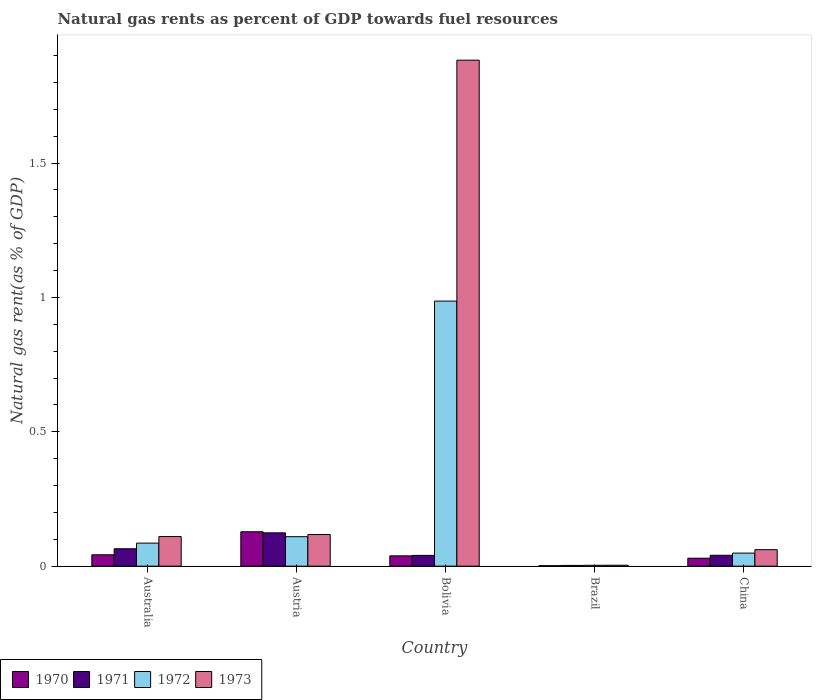How many different coloured bars are there?
Your response must be concise. 4. How many groups of bars are there?
Keep it short and to the point. 5. Are the number of bars on each tick of the X-axis equal?
Provide a short and direct response. Yes. What is the label of the 2nd group of bars from the left?
Give a very brief answer. Austria. In how many cases, is the number of bars for a given country not equal to the number of legend labels?
Provide a succinct answer. 0. What is the natural gas rent in 1971 in Brazil?
Keep it short and to the point. 0. Across all countries, what is the maximum natural gas rent in 1972?
Your response must be concise. 0.99. Across all countries, what is the minimum natural gas rent in 1973?
Provide a succinct answer. 0. In which country was the natural gas rent in 1971 minimum?
Provide a short and direct response. Brazil. What is the total natural gas rent in 1971 in the graph?
Your answer should be compact. 0.27. What is the difference between the natural gas rent in 1972 in Austria and that in Brazil?
Your answer should be very brief. 0.11. What is the difference between the natural gas rent in 1972 in Brazil and the natural gas rent in 1971 in Australia?
Your answer should be very brief. -0.06. What is the average natural gas rent in 1971 per country?
Give a very brief answer. 0.05. What is the difference between the natural gas rent of/in 1970 and natural gas rent of/in 1971 in Brazil?
Offer a very short reply. -0. What is the ratio of the natural gas rent in 1972 in Austria to that in Bolivia?
Your answer should be compact. 0.11. Is the natural gas rent in 1970 in Austria less than that in Brazil?
Ensure brevity in your answer.  No. What is the difference between the highest and the second highest natural gas rent in 1973?
Your answer should be very brief. -1.77. What is the difference between the highest and the lowest natural gas rent in 1972?
Provide a short and direct response. 0.98. In how many countries, is the natural gas rent in 1971 greater than the average natural gas rent in 1971 taken over all countries?
Your answer should be compact. 2. Is it the case that in every country, the sum of the natural gas rent in 1970 and natural gas rent in 1972 is greater than the sum of natural gas rent in 1971 and natural gas rent in 1973?
Offer a terse response. No. How many bars are there?
Keep it short and to the point. 20. Are all the bars in the graph horizontal?
Provide a short and direct response. No. Are the values on the major ticks of Y-axis written in scientific E-notation?
Provide a short and direct response. No. Does the graph contain any zero values?
Make the answer very short. No. Where does the legend appear in the graph?
Your answer should be very brief. Bottom left. How many legend labels are there?
Provide a succinct answer. 4. How are the legend labels stacked?
Provide a short and direct response. Horizontal. What is the title of the graph?
Your answer should be very brief. Natural gas rents as percent of GDP towards fuel resources. Does "1972" appear as one of the legend labels in the graph?
Your answer should be very brief. Yes. What is the label or title of the Y-axis?
Offer a terse response. Natural gas rent(as % of GDP). What is the Natural gas rent(as % of GDP) of 1970 in Australia?
Make the answer very short. 0.04. What is the Natural gas rent(as % of GDP) of 1971 in Australia?
Your answer should be very brief. 0.06. What is the Natural gas rent(as % of GDP) of 1972 in Australia?
Ensure brevity in your answer.  0.09. What is the Natural gas rent(as % of GDP) in 1973 in Australia?
Your answer should be very brief. 0.11. What is the Natural gas rent(as % of GDP) of 1970 in Austria?
Ensure brevity in your answer.  0.13. What is the Natural gas rent(as % of GDP) in 1971 in Austria?
Give a very brief answer. 0.12. What is the Natural gas rent(as % of GDP) of 1972 in Austria?
Offer a very short reply. 0.11. What is the Natural gas rent(as % of GDP) of 1973 in Austria?
Give a very brief answer. 0.12. What is the Natural gas rent(as % of GDP) in 1970 in Bolivia?
Offer a very short reply. 0.04. What is the Natural gas rent(as % of GDP) in 1971 in Bolivia?
Ensure brevity in your answer.  0.04. What is the Natural gas rent(as % of GDP) of 1972 in Bolivia?
Provide a short and direct response. 0.99. What is the Natural gas rent(as % of GDP) in 1973 in Bolivia?
Your answer should be very brief. 1.88. What is the Natural gas rent(as % of GDP) of 1970 in Brazil?
Make the answer very short. 0. What is the Natural gas rent(as % of GDP) in 1971 in Brazil?
Keep it short and to the point. 0. What is the Natural gas rent(as % of GDP) in 1972 in Brazil?
Your answer should be compact. 0. What is the Natural gas rent(as % of GDP) in 1973 in Brazil?
Keep it short and to the point. 0. What is the Natural gas rent(as % of GDP) of 1970 in China?
Provide a succinct answer. 0.03. What is the Natural gas rent(as % of GDP) in 1971 in China?
Offer a very short reply. 0.04. What is the Natural gas rent(as % of GDP) in 1972 in China?
Offer a very short reply. 0.05. What is the Natural gas rent(as % of GDP) in 1973 in China?
Your answer should be compact. 0.06. Across all countries, what is the maximum Natural gas rent(as % of GDP) in 1970?
Your answer should be very brief. 0.13. Across all countries, what is the maximum Natural gas rent(as % of GDP) in 1971?
Make the answer very short. 0.12. Across all countries, what is the maximum Natural gas rent(as % of GDP) in 1972?
Give a very brief answer. 0.99. Across all countries, what is the maximum Natural gas rent(as % of GDP) of 1973?
Provide a succinct answer. 1.88. Across all countries, what is the minimum Natural gas rent(as % of GDP) in 1970?
Keep it short and to the point. 0. Across all countries, what is the minimum Natural gas rent(as % of GDP) of 1971?
Provide a short and direct response. 0. Across all countries, what is the minimum Natural gas rent(as % of GDP) in 1972?
Offer a very short reply. 0. Across all countries, what is the minimum Natural gas rent(as % of GDP) in 1973?
Your response must be concise. 0. What is the total Natural gas rent(as % of GDP) of 1970 in the graph?
Offer a very short reply. 0.24. What is the total Natural gas rent(as % of GDP) of 1971 in the graph?
Offer a terse response. 0.27. What is the total Natural gas rent(as % of GDP) of 1972 in the graph?
Keep it short and to the point. 1.23. What is the total Natural gas rent(as % of GDP) in 1973 in the graph?
Offer a terse response. 2.18. What is the difference between the Natural gas rent(as % of GDP) of 1970 in Australia and that in Austria?
Provide a short and direct response. -0.09. What is the difference between the Natural gas rent(as % of GDP) of 1971 in Australia and that in Austria?
Your answer should be very brief. -0.06. What is the difference between the Natural gas rent(as % of GDP) of 1972 in Australia and that in Austria?
Ensure brevity in your answer.  -0.02. What is the difference between the Natural gas rent(as % of GDP) of 1973 in Australia and that in Austria?
Ensure brevity in your answer.  -0.01. What is the difference between the Natural gas rent(as % of GDP) of 1970 in Australia and that in Bolivia?
Your response must be concise. 0. What is the difference between the Natural gas rent(as % of GDP) in 1971 in Australia and that in Bolivia?
Provide a short and direct response. 0.02. What is the difference between the Natural gas rent(as % of GDP) of 1972 in Australia and that in Bolivia?
Make the answer very short. -0.9. What is the difference between the Natural gas rent(as % of GDP) in 1973 in Australia and that in Bolivia?
Your answer should be compact. -1.77. What is the difference between the Natural gas rent(as % of GDP) in 1970 in Australia and that in Brazil?
Your answer should be compact. 0.04. What is the difference between the Natural gas rent(as % of GDP) in 1971 in Australia and that in Brazil?
Give a very brief answer. 0.06. What is the difference between the Natural gas rent(as % of GDP) in 1972 in Australia and that in Brazil?
Make the answer very short. 0.08. What is the difference between the Natural gas rent(as % of GDP) of 1973 in Australia and that in Brazil?
Ensure brevity in your answer.  0.11. What is the difference between the Natural gas rent(as % of GDP) of 1970 in Australia and that in China?
Your answer should be very brief. 0.01. What is the difference between the Natural gas rent(as % of GDP) of 1971 in Australia and that in China?
Provide a succinct answer. 0.02. What is the difference between the Natural gas rent(as % of GDP) of 1972 in Australia and that in China?
Offer a very short reply. 0.04. What is the difference between the Natural gas rent(as % of GDP) of 1973 in Australia and that in China?
Make the answer very short. 0.05. What is the difference between the Natural gas rent(as % of GDP) in 1970 in Austria and that in Bolivia?
Offer a terse response. 0.09. What is the difference between the Natural gas rent(as % of GDP) of 1971 in Austria and that in Bolivia?
Ensure brevity in your answer.  0.08. What is the difference between the Natural gas rent(as % of GDP) of 1972 in Austria and that in Bolivia?
Ensure brevity in your answer.  -0.88. What is the difference between the Natural gas rent(as % of GDP) in 1973 in Austria and that in Bolivia?
Offer a very short reply. -1.77. What is the difference between the Natural gas rent(as % of GDP) of 1970 in Austria and that in Brazil?
Your answer should be compact. 0.13. What is the difference between the Natural gas rent(as % of GDP) of 1971 in Austria and that in Brazil?
Provide a succinct answer. 0.12. What is the difference between the Natural gas rent(as % of GDP) of 1972 in Austria and that in Brazil?
Your answer should be very brief. 0.11. What is the difference between the Natural gas rent(as % of GDP) in 1973 in Austria and that in Brazil?
Give a very brief answer. 0.11. What is the difference between the Natural gas rent(as % of GDP) of 1970 in Austria and that in China?
Your answer should be compact. 0.1. What is the difference between the Natural gas rent(as % of GDP) in 1971 in Austria and that in China?
Your response must be concise. 0.08. What is the difference between the Natural gas rent(as % of GDP) of 1972 in Austria and that in China?
Provide a succinct answer. 0.06. What is the difference between the Natural gas rent(as % of GDP) in 1973 in Austria and that in China?
Offer a terse response. 0.06. What is the difference between the Natural gas rent(as % of GDP) of 1970 in Bolivia and that in Brazil?
Provide a succinct answer. 0.04. What is the difference between the Natural gas rent(as % of GDP) in 1971 in Bolivia and that in Brazil?
Offer a very short reply. 0.04. What is the difference between the Natural gas rent(as % of GDP) in 1972 in Bolivia and that in Brazil?
Keep it short and to the point. 0.98. What is the difference between the Natural gas rent(as % of GDP) in 1973 in Bolivia and that in Brazil?
Provide a succinct answer. 1.88. What is the difference between the Natural gas rent(as % of GDP) of 1970 in Bolivia and that in China?
Give a very brief answer. 0.01. What is the difference between the Natural gas rent(as % of GDP) of 1971 in Bolivia and that in China?
Keep it short and to the point. -0. What is the difference between the Natural gas rent(as % of GDP) in 1972 in Bolivia and that in China?
Provide a short and direct response. 0.94. What is the difference between the Natural gas rent(as % of GDP) of 1973 in Bolivia and that in China?
Ensure brevity in your answer.  1.82. What is the difference between the Natural gas rent(as % of GDP) in 1970 in Brazil and that in China?
Give a very brief answer. -0.03. What is the difference between the Natural gas rent(as % of GDP) of 1971 in Brazil and that in China?
Make the answer very short. -0.04. What is the difference between the Natural gas rent(as % of GDP) in 1972 in Brazil and that in China?
Offer a very short reply. -0.05. What is the difference between the Natural gas rent(as % of GDP) in 1973 in Brazil and that in China?
Your answer should be very brief. -0.06. What is the difference between the Natural gas rent(as % of GDP) of 1970 in Australia and the Natural gas rent(as % of GDP) of 1971 in Austria?
Provide a succinct answer. -0.08. What is the difference between the Natural gas rent(as % of GDP) of 1970 in Australia and the Natural gas rent(as % of GDP) of 1972 in Austria?
Your answer should be compact. -0.07. What is the difference between the Natural gas rent(as % of GDP) in 1970 in Australia and the Natural gas rent(as % of GDP) in 1973 in Austria?
Keep it short and to the point. -0.08. What is the difference between the Natural gas rent(as % of GDP) of 1971 in Australia and the Natural gas rent(as % of GDP) of 1972 in Austria?
Make the answer very short. -0.04. What is the difference between the Natural gas rent(as % of GDP) in 1971 in Australia and the Natural gas rent(as % of GDP) in 1973 in Austria?
Provide a succinct answer. -0.05. What is the difference between the Natural gas rent(as % of GDP) of 1972 in Australia and the Natural gas rent(as % of GDP) of 1973 in Austria?
Provide a short and direct response. -0.03. What is the difference between the Natural gas rent(as % of GDP) in 1970 in Australia and the Natural gas rent(as % of GDP) in 1971 in Bolivia?
Provide a short and direct response. 0. What is the difference between the Natural gas rent(as % of GDP) in 1970 in Australia and the Natural gas rent(as % of GDP) in 1972 in Bolivia?
Keep it short and to the point. -0.94. What is the difference between the Natural gas rent(as % of GDP) of 1970 in Australia and the Natural gas rent(as % of GDP) of 1973 in Bolivia?
Your answer should be very brief. -1.84. What is the difference between the Natural gas rent(as % of GDP) of 1971 in Australia and the Natural gas rent(as % of GDP) of 1972 in Bolivia?
Ensure brevity in your answer.  -0.92. What is the difference between the Natural gas rent(as % of GDP) in 1971 in Australia and the Natural gas rent(as % of GDP) in 1973 in Bolivia?
Offer a terse response. -1.82. What is the difference between the Natural gas rent(as % of GDP) in 1972 in Australia and the Natural gas rent(as % of GDP) in 1973 in Bolivia?
Offer a very short reply. -1.8. What is the difference between the Natural gas rent(as % of GDP) in 1970 in Australia and the Natural gas rent(as % of GDP) in 1971 in Brazil?
Keep it short and to the point. 0.04. What is the difference between the Natural gas rent(as % of GDP) in 1970 in Australia and the Natural gas rent(as % of GDP) in 1972 in Brazil?
Your answer should be compact. 0.04. What is the difference between the Natural gas rent(as % of GDP) in 1970 in Australia and the Natural gas rent(as % of GDP) in 1973 in Brazil?
Give a very brief answer. 0.04. What is the difference between the Natural gas rent(as % of GDP) in 1971 in Australia and the Natural gas rent(as % of GDP) in 1972 in Brazil?
Give a very brief answer. 0.06. What is the difference between the Natural gas rent(as % of GDP) of 1971 in Australia and the Natural gas rent(as % of GDP) of 1973 in Brazil?
Your response must be concise. 0.06. What is the difference between the Natural gas rent(as % of GDP) in 1972 in Australia and the Natural gas rent(as % of GDP) in 1973 in Brazil?
Your answer should be very brief. 0.08. What is the difference between the Natural gas rent(as % of GDP) in 1970 in Australia and the Natural gas rent(as % of GDP) in 1971 in China?
Give a very brief answer. 0. What is the difference between the Natural gas rent(as % of GDP) in 1970 in Australia and the Natural gas rent(as % of GDP) in 1972 in China?
Make the answer very short. -0.01. What is the difference between the Natural gas rent(as % of GDP) of 1970 in Australia and the Natural gas rent(as % of GDP) of 1973 in China?
Your answer should be compact. -0.02. What is the difference between the Natural gas rent(as % of GDP) in 1971 in Australia and the Natural gas rent(as % of GDP) in 1972 in China?
Your answer should be compact. 0.02. What is the difference between the Natural gas rent(as % of GDP) in 1971 in Australia and the Natural gas rent(as % of GDP) in 1973 in China?
Ensure brevity in your answer.  0. What is the difference between the Natural gas rent(as % of GDP) in 1972 in Australia and the Natural gas rent(as % of GDP) in 1973 in China?
Provide a short and direct response. 0.02. What is the difference between the Natural gas rent(as % of GDP) of 1970 in Austria and the Natural gas rent(as % of GDP) of 1971 in Bolivia?
Make the answer very short. 0.09. What is the difference between the Natural gas rent(as % of GDP) in 1970 in Austria and the Natural gas rent(as % of GDP) in 1972 in Bolivia?
Your answer should be compact. -0.86. What is the difference between the Natural gas rent(as % of GDP) of 1970 in Austria and the Natural gas rent(as % of GDP) of 1973 in Bolivia?
Keep it short and to the point. -1.75. What is the difference between the Natural gas rent(as % of GDP) in 1971 in Austria and the Natural gas rent(as % of GDP) in 1972 in Bolivia?
Provide a succinct answer. -0.86. What is the difference between the Natural gas rent(as % of GDP) of 1971 in Austria and the Natural gas rent(as % of GDP) of 1973 in Bolivia?
Ensure brevity in your answer.  -1.76. What is the difference between the Natural gas rent(as % of GDP) in 1972 in Austria and the Natural gas rent(as % of GDP) in 1973 in Bolivia?
Your response must be concise. -1.77. What is the difference between the Natural gas rent(as % of GDP) in 1970 in Austria and the Natural gas rent(as % of GDP) in 1971 in Brazil?
Your response must be concise. 0.13. What is the difference between the Natural gas rent(as % of GDP) of 1970 in Austria and the Natural gas rent(as % of GDP) of 1972 in Brazil?
Give a very brief answer. 0.12. What is the difference between the Natural gas rent(as % of GDP) in 1970 in Austria and the Natural gas rent(as % of GDP) in 1973 in Brazil?
Offer a terse response. 0.12. What is the difference between the Natural gas rent(as % of GDP) in 1971 in Austria and the Natural gas rent(as % of GDP) in 1972 in Brazil?
Give a very brief answer. 0.12. What is the difference between the Natural gas rent(as % of GDP) in 1971 in Austria and the Natural gas rent(as % of GDP) in 1973 in Brazil?
Offer a terse response. 0.12. What is the difference between the Natural gas rent(as % of GDP) of 1972 in Austria and the Natural gas rent(as % of GDP) of 1973 in Brazil?
Keep it short and to the point. 0.11. What is the difference between the Natural gas rent(as % of GDP) in 1970 in Austria and the Natural gas rent(as % of GDP) in 1971 in China?
Provide a short and direct response. 0.09. What is the difference between the Natural gas rent(as % of GDP) in 1970 in Austria and the Natural gas rent(as % of GDP) in 1972 in China?
Your response must be concise. 0.08. What is the difference between the Natural gas rent(as % of GDP) in 1970 in Austria and the Natural gas rent(as % of GDP) in 1973 in China?
Give a very brief answer. 0.07. What is the difference between the Natural gas rent(as % of GDP) of 1971 in Austria and the Natural gas rent(as % of GDP) of 1972 in China?
Ensure brevity in your answer.  0.08. What is the difference between the Natural gas rent(as % of GDP) of 1971 in Austria and the Natural gas rent(as % of GDP) of 1973 in China?
Provide a short and direct response. 0.06. What is the difference between the Natural gas rent(as % of GDP) of 1972 in Austria and the Natural gas rent(as % of GDP) of 1973 in China?
Offer a very short reply. 0.05. What is the difference between the Natural gas rent(as % of GDP) of 1970 in Bolivia and the Natural gas rent(as % of GDP) of 1971 in Brazil?
Offer a terse response. 0.04. What is the difference between the Natural gas rent(as % of GDP) in 1970 in Bolivia and the Natural gas rent(as % of GDP) in 1972 in Brazil?
Your response must be concise. 0.04. What is the difference between the Natural gas rent(as % of GDP) of 1970 in Bolivia and the Natural gas rent(as % of GDP) of 1973 in Brazil?
Provide a succinct answer. 0.03. What is the difference between the Natural gas rent(as % of GDP) of 1971 in Bolivia and the Natural gas rent(as % of GDP) of 1972 in Brazil?
Your answer should be very brief. 0.04. What is the difference between the Natural gas rent(as % of GDP) of 1971 in Bolivia and the Natural gas rent(as % of GDP) of 1973 in Brazil?
Give a very brief answer. 0.04. What is the difference between the Natural gas rent(as % of GDP) of 1972 in Bolivia and the Natural gas rent(as % of GDP) of 1973 in Brazil?
Make the answer very short. 0.98. What is the difference between the Natural gas rent(as % of GDP) of 1970 in Bolivia and the Natural gas rent(as % of GDP) of 1971 in China?
Provide a short and direct response. -0. What is the difference between the Natural gas rent(as % of GDP) of 1970 in Bolivia and the Natural gas rent(as % of GDP) of 1972 in China?
Ensure brevity in your answer.  -0.01. What is the difference between the Natural gas rent(as % of GDP) in 1970 in Bolivia and the Natural gas rent(as % of GDP) in 1973 in China?
Your response must be concise. -0.02. What is the difference between the Natural gas rent(as % of GDP) of 1971 in Bolivia and the Natural gas rent(as % of GDP) of 1972 in China?
Keep it short and to the point. -0.01. What is the difference between the Natural gas rent(as % of GDP) of 1971 in Bolivia and the Natural gas rent(as % of GDP) of 1973 in China?
Your answer should be very brief. -0.02. What is the difference between the Natural gas rent(as % of GDP) of 1972 in Bolivia and the Natural gas rent(as % of GDP) of 1973 in China?
Your answer should be compact. 0.92. What is the difference between the Natural gas rent(as % of GDP) of 1970 in Brazil and the Natural gas rent(as % of GDP) of 1971 in China?
Ensure brevity in your answer.  -0.04. What is the difference between the Natural gas rent(as % of GDP) of 1970 in Brazil and the Natural gas rent(as % of GDP) of 1972 in China?
Offer a terse response. -0.05. What is the difference between the Natural gas rent(as % of GDP) in 1970 in Brazil and the Natural gas rent(as % of GDP) in 1973 in China?
Keep it short and to the point. -0.06. What is the difference between the Natural gas rent(as % of GDP) of 1971 in Brazil and the Natural gas rent(as % of GDP) of 1972 in China?
Ensure brevity in your answer.  -0.05. What is the difference between the Natural gas rent(as % of GDP) in 1971 in Brazil and the Natural gas rent(as % of GDP) in 1973 in China?
Your answer should be very brief. -0.06. What is the difference between the Natural gas rent(as % of GDP) of 1972 in Brazil and the Natural gas rent(as % of GDP) of 1973 in China?
Your answer should be very brief. -0.06. What is the average Natural gas rent(as % of GDP) of 1970 per country?
Your answer should be very brief. 0.05. What is the average Natural gas rent(as % of GDP) in 1971 per country?
Your response must be concise. 0.05. What is the average Natural gas rent(as % of GDP) in 1972 per country?
Offer a terse response. 0.25. What is the average Natural gas rent(as % of GDP) of 1973 per country?
Offer a very short reply. 0.44. What is the difference between the Natural gas rent(as % of GDP) of 1970 and Natural gas rent(as % of GDP) of 1971 in Australia?
Provide a short and direct response. -0.02. What is the difference between the Natural gas rent(as % of GDP) in 1970 and Natural gas rent(as % of GDP) in 1972 in Australia?
Offer a very short reply. -0.04. What is the difference between the Natural gas rent(as % of GDP) in 1970 and Natural gas rent(as % of GDP) in 1973 in Australia?
Your answer should be very brief. -0.07. What is the difference between the Natural gas rent(as % of GDP) of 1971 and Natural gas rent(as % of GDP) of 1972 in Australia?
Make the answer very short. -0.02. What is the difference between the Natural gas rent(as % of GDP) in 1971 and Natural gas rent(as % of GDP) in 1973 in Australia?
Give a very brief answer. -0.05. What is the difference between the Natural gas rent(as % of GDP) in 1972 and Natural gas rent(as % of GDP) in 1973 in Australia?
Keep it short and to the point. -0.02. What is the difference between the Natural gas rent(as % of GDP) in 1970 and Natural gas rent(as % of GDP) in 1971 in Austria?
Offer a terse response. 0. What is the difference between the Natural gas rent(as % of GDP) in 1970 and Natural gas rent(as % of GDP) in 1972 in Austria?
Keep it short and to the point. 0.02. What is the difference between the Natural gas rent(as % of GDP) of 1970 and Natural gas rent(as % of GDP) of 1973 in Austria?
Your answer should be compact. 0.01. What is the difference between the Natural gas rent(as % of GDP) of 1971 and Natural gas rent(as % of GDP) of 1972 in Austria?
Provide a short and direct response. 0.01. What is the difference between the Natural gas rent(as % of GDP) in 1971 and Natural gas rent(as % of GDP) in 1973 in Austria?
Offer a terse response. 0.01. What is the difference between the Natural gas rent(as % of GDP) of 1972 and Natural gas rent(as % of GDP) of 1973 in Austria?
Ensure brevity in your answer.  -0.01. What is the difference between the Natural gas rent(as % of GDP) of 1970 and Natural gas rent(as % of GDP) of 1971 in Bolivia?
Offer a very short reply. -0. What is the difference between the Natural gas rent(as % of GDP) of 1970 and Natural gas rent(as % of GDP) of 1972 in Bolivia?
Make the answer very short. -0.95. What is the difference between the Natural gas rent(as % of GDP) of 1970 and Natural gas rent(as % of GDP) of 1973 in Bolivia?
Give a very brief answer. -1.84. What is the difference between the Natural gas rent(as % of GDP) in 1971 and Natural gas rent(as % of GDP) in 1972 in Bolivia?
Offer a terse response. -0.95. What is the difference between the Natural gas rent(as % of GDP) in 1971 and Natural gas rent(as % of GDP) in 1973 in Bolivia?
Keep it short and to the point. -1.84. What is the difference between the Natural gas rent(as % of GDP) of 1972 and Natural gas rent(as % of GDP) of 1973 in Bolivia?
Make the answer very short. -0.9. What is the difference between the Natural gas rent(as % of GDP) of 1970 and Natural gas rent(as % of GDP) of 1971 in Brazil?
Offer a terse response. -0. What is the difference between the Natural gas rent(as % of GDP) of 1970 and Natural gas rent(as % of GDP) of 1972 in Brazil?
Provide a short and direct response. -0. What is the difference between the Natural gas rent(as % of GDP) in 1970 and Natural gas rent(as % of GDP) in 1973 in Brazil?
Your answer should be compact. -0. What is the difference between the Natural gas rent(as % of GDP) of 1971 and Natural gas rent(as % of GDP) of 1972 in Brazil?
Ensure brevity in your answer.  -0. What is the difference between the Natural gas rent(as % of GDP) in 1971 and Natural gas rent(as % of GDP) in 1973 in Brazil?
Keep it short and to the point. -0. What is the difference between the Natural gas rent(as % of GDP) in 1972 and Natural gas rent(as % of GDP) in 1973 in Brazil?
Your answer should be compact. -0. What is the difference between the Natural gas rent(as % of GDP) of 1970 and Natural gas rent(as % of GDP) of 1971 in China?
Offer a terse response. -0.01. What is the difference between the Natural gas rent(as % of GDP) of 1970 and Natural gas rent(as % of GDP) of 1972 in China?
Keep it short and to the point. -0.02. What is the difference between the Natural gas rent(as % of GDP) in 1970 and Natural gas rent(as % of GDP) in 1973 in China?
Offer a terse response. -0.03. What is the difference between the Natural gas rent(as % of GDP) of 1971 and Natural gas rent(as % of GDP) of 1972 in China?
Provide a succinct answer. -0.01. What is the difference between the Natural gas rent(as % of GDP) of 1971 and Natural gas rent(as % of GDP) of 1973 in China?
Your answer should be very brief. -0.02. What is the difference between the Natural gas rent(as % of GDP) of 1972 and Natural gas rent(as % of GDP) of 1973 in China?
Your response must be concise. -0.01. What is the ratio of the Natural gas rent(as % of GDP) of 1970 in Australia to that in Austria?
Ensure brevity in your answer.  0.33. What is the ratio of the Natural gas rent(as % of GDP) of 1971 in Australia to that in Austria?
Provide a short and direct response. 0.52. What is the ratio of the Natural gas rent(as % of GDP) of 1972 in Australia to that in Austria?
Offer a terse response. 0.78. What is the ratio of the Natural gas rent(as % of GDP) of 1973 in Australia to that in Austria?
Give a very brief answer. 0.94. What is the ratio of the Natural gas rent(as % of GDP) in 1970 in Australia to that in Bolivia?
Your response must be concise. 1.1. What is the ratio of the Natural gas rent(as % of GDP) of 1971 in Australia to that in Bolivia?
Provide a succinct answer. 1.61. What is the ratio of the Natural gas rent(as % of GDP) in 1972 in Australia to that in Bolivia?
Your answer should be compact. 0.09. What is the ratio of the Natural gas rent(as % of GDP) in 1973 in Australia to that in Bolivia?
Your answer should be compact. 0.06. What is the ratio of the Natural gas rent(as % of GDP) of 1970 in Australia to that in Brazil?
Keep it short and to the point. 23.81. What is the ratio of the Natural gas rent(as % of GDP) in 1971 in Australia to that in Brazil?
Your answer should be compact. 23.6. What is the ratio of the Natural gas rent(as % of GDP) in 1972 in Australia to that in Brazil?
Make the answer very short. 25.86. What is the ratio of the Natural gas rent(as % of GDP) in 1973 in Australia to that in Brazil?
Give a very brief answer. 31.58. What is the ratio of the Natural gas rent(as % of GDP) of 1970 in Australia to that in China?
Offer a very short reply. 1.43. What is the ratio of the Natural gas rent(as % of GDP) in 1971 in Australia to that in China?
Your answer should be compact. 1.6. What is the ratio of the Natural gas rent(as % of GDP) of 1972 in Australia to that in China?
Offer a terse response. 1.76. What is the ratio of the Natural gas rent(as % of GDP) of 1973 in Australia to that in China?
Give a very brief answer. 1.79. What is the ratio of the Natural gas rent(as % of GDP) of 1970 in Austria to that in Bolivia?
Your answer should be compact. 3.34. What is the ratio of the Natural gas rent(as % of GDP) of 1971 in Austria to that in Bolivia?
Your answer should be compact. 3.09. What is the ratio of the Natural gas rent(as % of GDP) of 1972 in Austria to that in Bolivia?
Your response must be concise. 0.11. What is the ratio of the Natural gas rent(as % of GDP) of 1973 in Austria to that in Bolivia?
Your response must be concise. 0.06. What is the ratio of the Natural gas rent(as % of GDP) of 1970 in Austria to that in Brazil?
Offer a terse response. 72. What is the ratio of the Natural gas rent(as % of GDP) of 1971 in Austria to that in Brazil?
Your response must be concise. 45.2. What is the ratio of the Natural gas rent(as % of GDP) of 1972 in Austria to that in Brazil?
Offer a very short reply. 33.07. What is the ratio of the Natural gas rent(as % of GDP) in 1973 in Austria to that in Brazil?
Offer a terse response. 33.74. What is the ratio of the Natural gas rent(as % of GDP) of 1970 in Austria to that in China?
Offer a terse response. 4.32. What is the ratio of the Natural gas rent(as % of GDP) of 1971 in Austria to that in China?
Your answer should be very brief. 3.06. What is the ratio of the Natural gas rent(as % of GDP) in 1972 in Austria to that in China?
Provide a succinct answer. 2.25. What is the ratio of the Natural gas rent(as % of GDP) of 1973 in Austria to that in China?
Your answer should be very brief. 1.92. What is the ratio of the Natural gas rent(as % of GDP) of 1970 in Bolivia to that in Brazil?
Make the answer very short. 21.58. What is the ratio of the Natural gas rent(as % of GDP) in 1971 in Bolivia to that in Brazil?
Make the answer very short. 14.62. What is the ratio of the Natural gas rent(as % of GDP) in 1972 in Bolivia to that in Brazil?
Your response must be concise. 297.41. What is the ratio of the Natural gas rent(as % of GDP) in 1973 in Bolivia to that in Brazil?
Offer a terse response. 539.46. What is the ratio of the Natural gas rent(as % of GDP) of 1970 in Bolivia to that in China?
Make the answer very short. 1.3. What is the ratio of the Natural gas rent(as % of GDP) of 1972 in Bolivia to that in China?
Provide a succinct answer. 20.28. What is the ratio of the Natural gas rent(as % of GDP) of 1973 in Bolivia to that in China?
Your response must be concise. 30.65. What is the ratio of the Natural gas rent(as % of GDP) in 1971 in Brazil to that in China?
Provide a succinct answer. 0.07. What is the ratio of the Natural gas rent(as % of GDP) in 1972 in Brazil to that in China?
Give a very brief answer. 0.07. What is the ratio of the Natural gas rent(as % of GDP) of 1973 in Brazil to that in China?
Your answer should be very brief. 0.06. What is the difference between the highest and the second highest Natural gas rent(as % of GDP) of 1970?
Your answer should be compact. 0.09. What is the difference between the highest and the second highest Natural gas rent(as % of GDP) of 1971?
Offer a terse response. 0.06. What is the difference between the highest and the second highest Natural gas rent(as % of GDP) in 1972?
Your answer should be compact. 0.88. What is the difference between the highest and the second highest Natural gas rent(as % of GDP) of 1973?
Provide a short and direct response. 1.77. What is the difference between the highest and the lowest Natural gas rent(as % of GDP) in 1970?
Offer a very short reply. 0.13. What is the difference between the highest and the lowest Natural gas rent(as % of GDP) of 1971?
Ensure brevity in your answer.  0.12. What is the difference between the highest and the lowest Natural gas rent(as % of GDP) in 1973?
Keep it short and to the point. 1.88. 